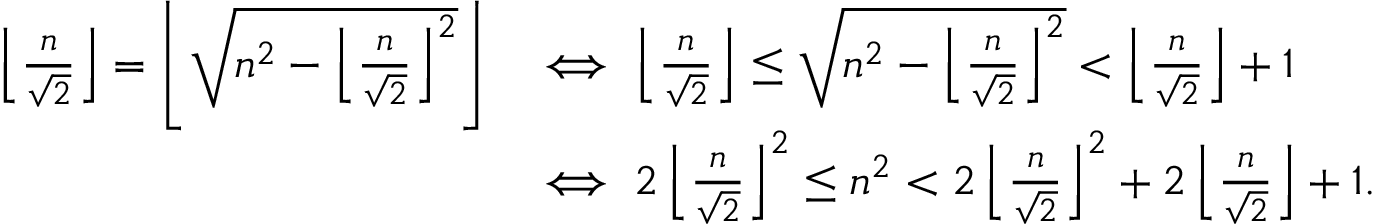<formula> <loc_0><loc_0><loc_500><loc_500>\begin{array} { r l } { \left \lfloor \frac { n } { \sqrt { 2 } } \right \rfloor = \left \lfloor \sqrt { n ^ { 2 } - \left \lfloor \frac { n } { \sqrt { 2 } } \right \rfloor ^ { 2 } } \right \rfloor } & { \iff \left \lfloor \frac { n } { \sqrt { 2 } } \right \rfloor \leq \sqrt { n ^ { 2 } - \left \lfloor \frac { n } { \sqrt { 2 } } \right \rfloor ^ { 2 } } < \left \lfloor \frac { n } { \sqrt { 2 } } \right \rfloor + 1 } \\ & { \iff 2 \left \lfloor \frac { n } { \sqrt { 2 } } \right \rfloor ^ { 2 } \leq n ^ { 2 } < 2 \left \lfloor \frac { n } { \sqrt { 2 } } \right \rfloor ^ { 2 } + 2 \left \lfloor \frac { n } { \sqrt { 2 } } \right \rfloor + 1 . } \end{array}</formula> 